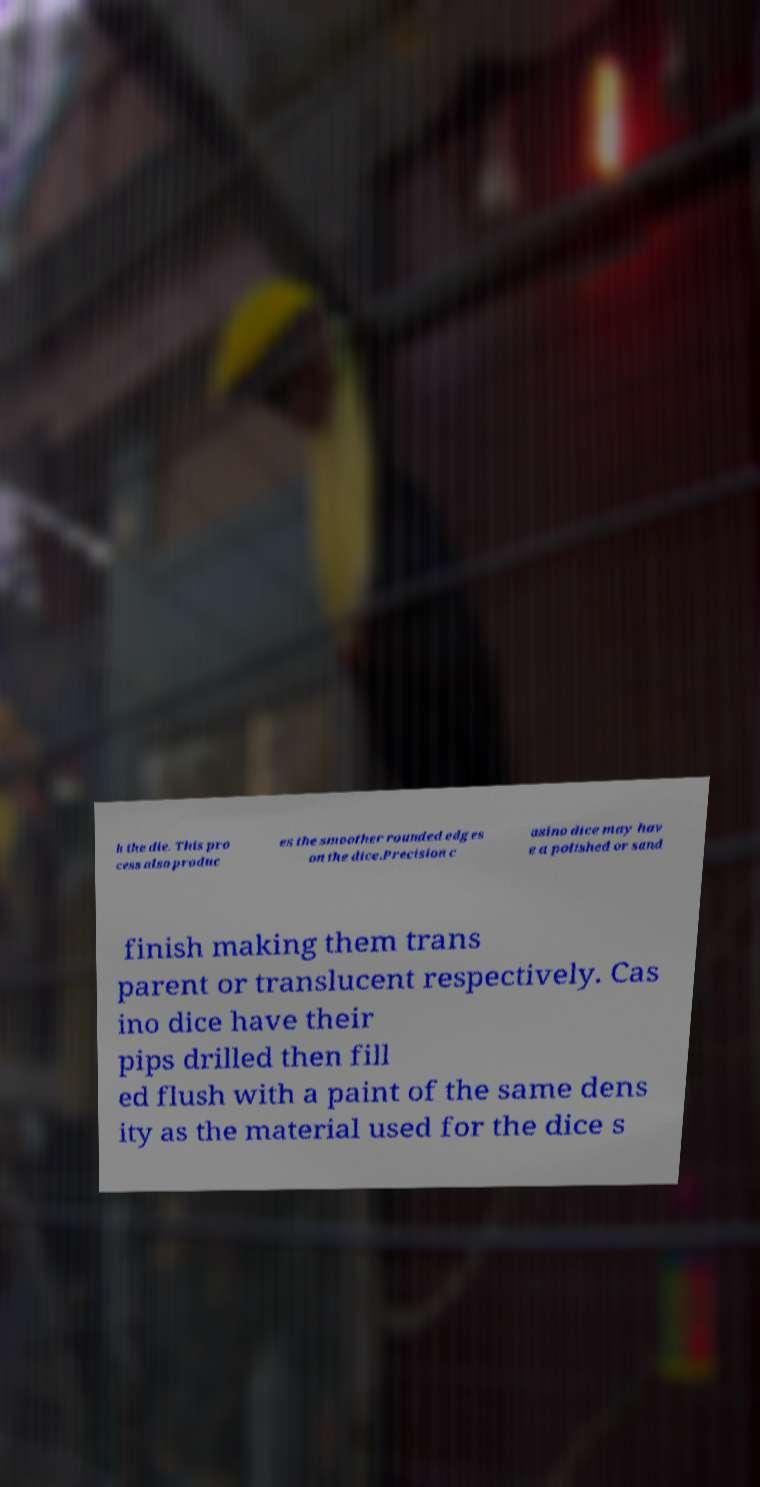I need the written content from this picture converted into text. Can you do that? h the die. This pro cess also produc es the smoother rounded edges on the dice.Precision c asino dice may hav e a polished or sand finish making them trans parent or translucent respectively. Cas ino dice have their pips drilled then fill ed flush with a paint of the same dens ity as the material used for the dice s 